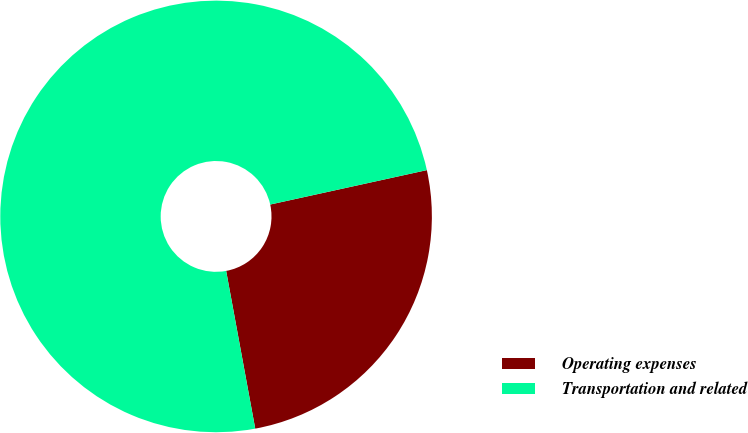Convert chart. <chart><loc_0><loc_0><loc_500><loc_500><pie_chart><fcel>Operating expenses<fcel>Transportation and related<nl><fcel>25.54%<fcel>74.46%<nl></chart> 